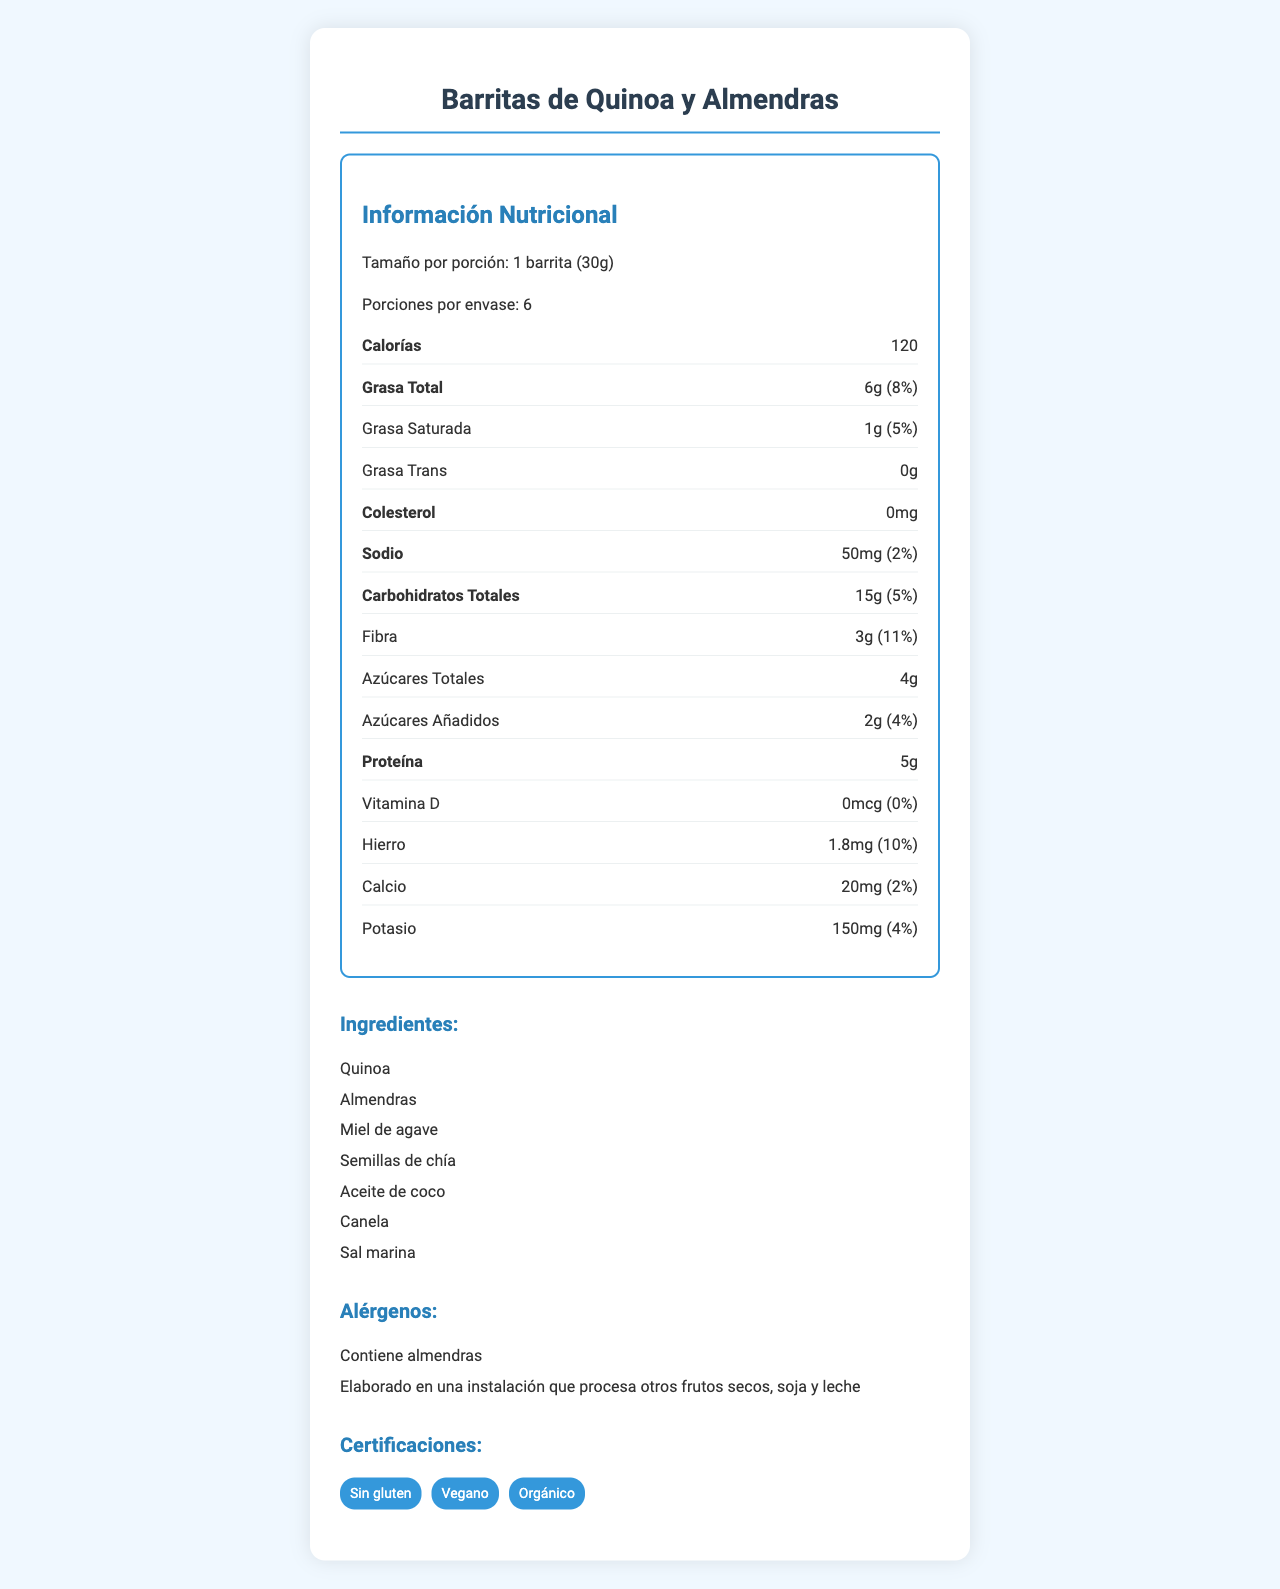what es el nombre del producto? El nombre del producto se menciona en la parte superior del documento y como título principal.
Answer: Barritas de Quinoa y Almendras ¿Cuántas calorías tiene una porción? Las calorías por porción se indican en la sección de "Información Nutricional".
Answer: 120 ¿Cuál es el tamaño de la porción de este producto? El tamaño de la porción se especifica en la sección de información nutricional.
Answer: 1 barrita (30g) ¿Cuántos gramos de fibra tiene cada barrita? La cantidad de fibra por porción se indica en la sección de "Fibra" dentro de la "Información Nutricional".
Answer: 3g ¿Cuáles son los ingredientes principales? La lista de ingredientes se encuentra en la sección de "Ingredientes".
Answer: Quinoa, Almendras, Miel de agave, Semillas de chía, Aceite de coco, Canela, Sal marina ¿Cuánto colesterol tiene una porción? La cantidad de colesterol por porción se especifica en la sección de información nutricional bajo "Colesterol".
Answer: 0mg ¿Cuántos gramos de azúcar añadido tiene una porción? A. 1g B. 2g C. 4g D. 5g La cantidad de azúcares añadidos se indica como "2g" en la información nutricional.
Answer: B ¿Cuántas porciones contiene un envase? A. 4 B. 5 C. 6 D. 7 El documento menciona que hay 6 porciones por envase en la sección de información nutricional.
Answer: C ¿Este producto contiene gluten? En la sección de "Certificaciones" se menciona que el producto es "Sin gluten".
Answer: No ¿Cuál es la cantidad de hierro por porción? La cantidad de hierro se especifica en la sección de información nutricional bajo las vitaminas.
Answer: 1.8mg ¿Qué técnicas responsivas se utilizan para el diseño adaptable? Estas técnicas están mencionadas en la sección de diseño adaptable en el documento.
Answer: Diseño de cuadrícula flexible, Imágenes flexibles, Media queries, Tipografía fluida ¿El producto es adecuado para veganos? En la sección de certificaciones se menciona que el producto es "Vegano".
Answer: Sí Resumen del documento El documento presenta de manera detallada y organizada la información nutricional de un snack saludable, describiendo sus componentes, ingredientes, alérgenos, certificaciones y detalles sobre el diseño responsivo y consideraciones de UX para asegurar su accesibilidad y legibilidad en dispositivos móviles.
Answer: El documento proporciona información nutricional sobre las "Barritas de Quinoa y Almendras", incluyendo detalles sobre tamaño de la porción, calorías, contenidos de grasa, colesterol, sodio, carbohidratos, fibra, azúcares, proteína y vitaminas. Además, se enumeran los ingredientes, advertencias de alérgenos, certificaciones y detalles de su diseño adaptable para dispositivos móviles, junto con consideraciones de experiencia de usuario. ¿Cuál es el país de origen de los ingredientes? La información sobre el origen de los ingredientes no se presenta de manera visual en el documento; por lo tanto, no se puede determinar.
Answer: No se puede determinar 